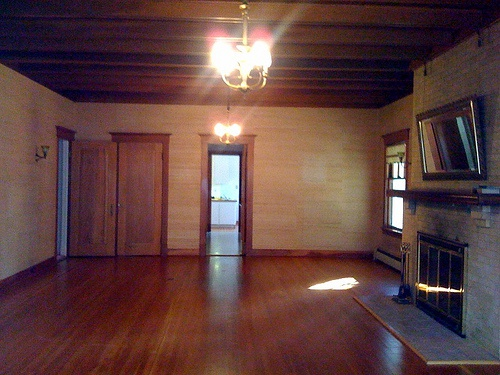Describe the objects in this image and their specific colors. I can see various objects in this image with different colors. 